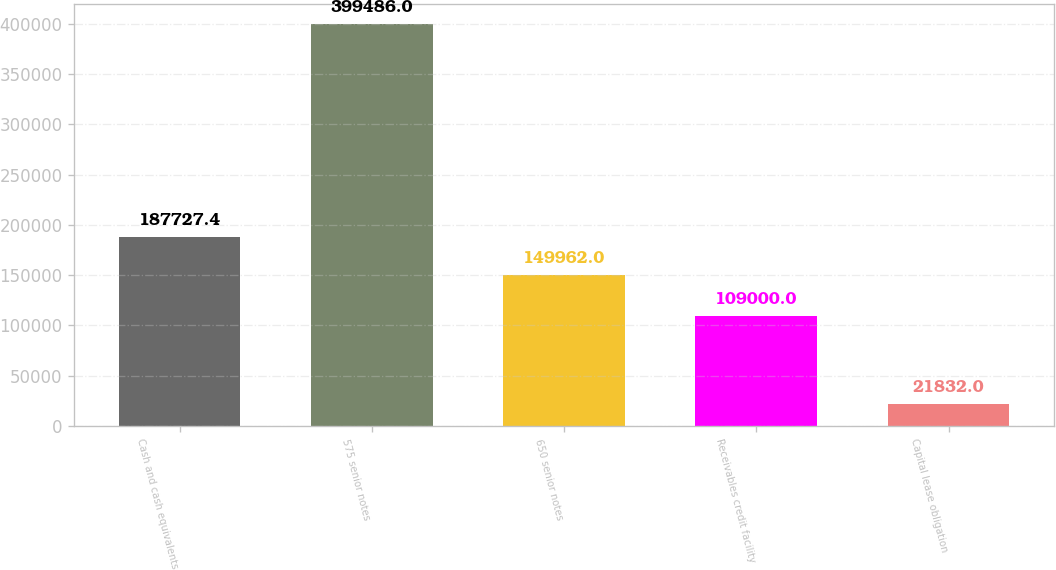Convert chart to OTSL. <chart><loc_0><loc_0><loc_500><loc_500><bar_chart><fcel>Cash and cash equivalents<fcel>575 senior notes<fcel>650 senior notes<fcel>Receivables credit facility<fcel>Capital lease obligation<nl><fcel>187727<fcel>399486<fcel>149962<fcel>109000<fcel>21832<nl></chart> 